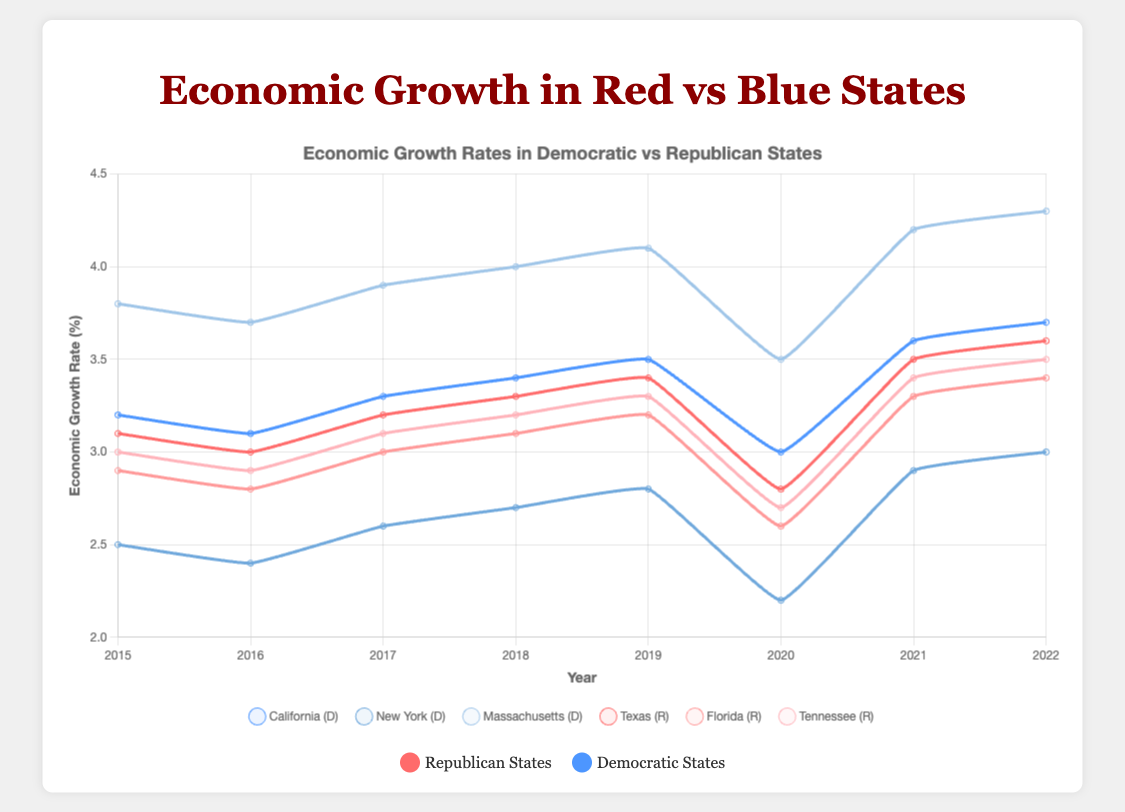Which state had the highest economic growth rate in 2022? In 2022, Massachusetts had the highest economic growth rate among the states listed. The figure shows Massachusetts at 4.3%, which is higher than all other states.
Answer: Massachusetts Which state had a greater economic growth rate in 2020, Texas or California? Looking at the 2020 data points for Texas and California, California had a growth rate of 3.0%, while Texas had a lower growth rate of 2.8%. Thus, California had a greater economic growth rate.
Answer: California How does the average economic growth rate of Democratic states compare to Republican states in 2021? The economic growth rates in Democratic states (California, New York, Massachusetts) are 3.6%, 2.9%, and 4.2% respectively. The average for these is (3.6 + 2.9 + 4.2) / 3 = 3.57%. In Republican states (Texas, Florida, Tennessee), the rates are 3.5%, 3.3%, and 3.4%, giving us an average of (3.5 + 3.3 + 3.4) / 3 = 3.4%. Comparing these, Democratic states have a slightly higher average growth rate in 2021.
Answer: Democratic states What is the trend in economic growth for New York from 2015 to 2022? The economic growth rate in New York shows a general trend of decline from 2015 to 2020, dropping from 2.5% to 2.2%. After 2020, there is an upward trend, reaching 3.0% by 2022.
Answer: General decline followed by an upward trend Compare the economic growth rates of Massachusetts and Texas in 2019. Which state had the higher growth, and by how much? In 2019, Massachusetts had a growth rate of 4.1%, and Texas had a rate of 3.4%. The difference in growth rates is 4.1% - 3.4% = 0.7%. Massachusetts had a higher growth rate by 0.7%.
Answer: Massachusetts by 0.7% Which state experienced the largest decrease in economic growth rate from 2019 to 2020? From 2019 to 2020, California's growth rate decreased from 3.5% to 3.0%, a drop of 0.5%. New York dropped from 2.8% to 2.2%, a drop of 0.6%. Massachusetts fell from 4.1% to 3.5%, a drop of 0.6%. Texas decreased from 3.4% to 2.8%, a drop of 0.6%. Florida fell from 3.2% to 2.6%, a drop of 0.6%. Tennessee went from 3.3% to 2.7%, a drop of 0.6%. Thus, New York, Massachusetts, Texas, Florida, and Tennessee all had the largest decrease of 0.6%.
Answer: New York, Massachusetts, Texas, Florida, Tennessee What are the economic growth trends in the states governed by the Republican Party from 2015 to 2022? Texas, Florida, and Tennessee show similar trends. Their growth rates steadily increased from 2015 until 2019. There was a decline in 2020 and then the growth rates began to rise again in 2021 and continued in 2022, showing a pattern of growth, decline, and recovery.
Answer: Growth, decline in 2020, recovery What is the combined economic growth rate for California and Texas in 2018? In 2018, California had a growth rate of 3.4% and Texas had 3.3%. The combined rate is 3.4% + 3.3% = 6.7%.
Answer: 6.7% 